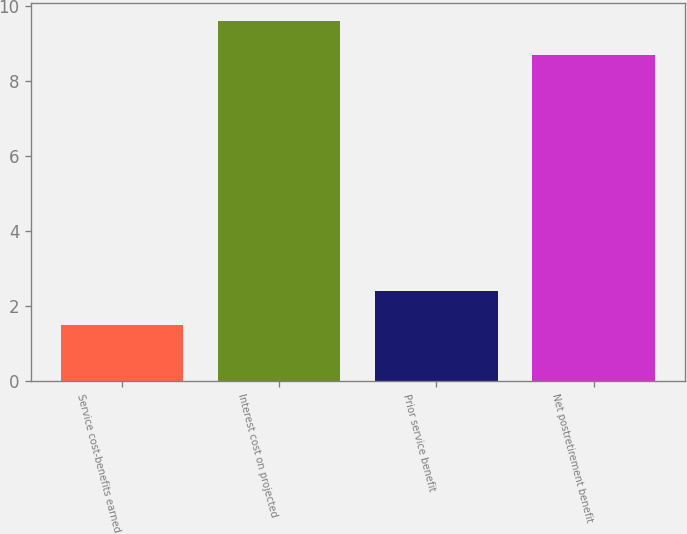<chart> <loc_0><loc_0><loc_500><loc_500><bar_chart><fcel>Service cost-benefits earned<fcel>Interest cost on projected<fcel>Prior service benefit<fcel>Net postretirement benefit<nl><fcel>1.5<fcel>9.6<fcel>2.4<fcel>8.7<nl></chart> 